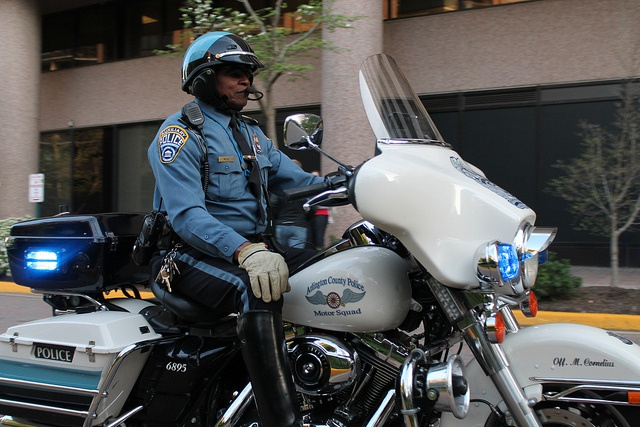Describe the objects in this image and their specific colors. I can see motorcycle in gray, black, lightgray, and darkgray tones and people in gray, black, and blue tones in this image. 